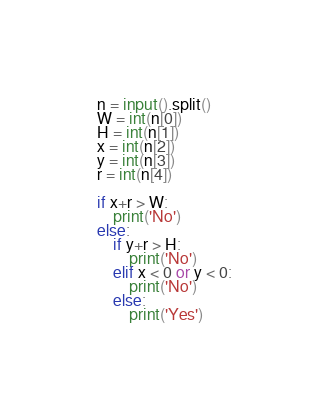Convert code to text. <code><loc_0><loc_0><loc_500><loc_500><_Python_>n = input().split()
W = int(n[0])
H = int(n[1])
x = int(n[2])
y = int(n[3])
r = int(n[4])

if x+r > W:
    print('No')
else:
    if y+r > H:
        print('No')
    elif x < 0 or y < 0:
        print('No')
    else:
        print('Yes')</code> 